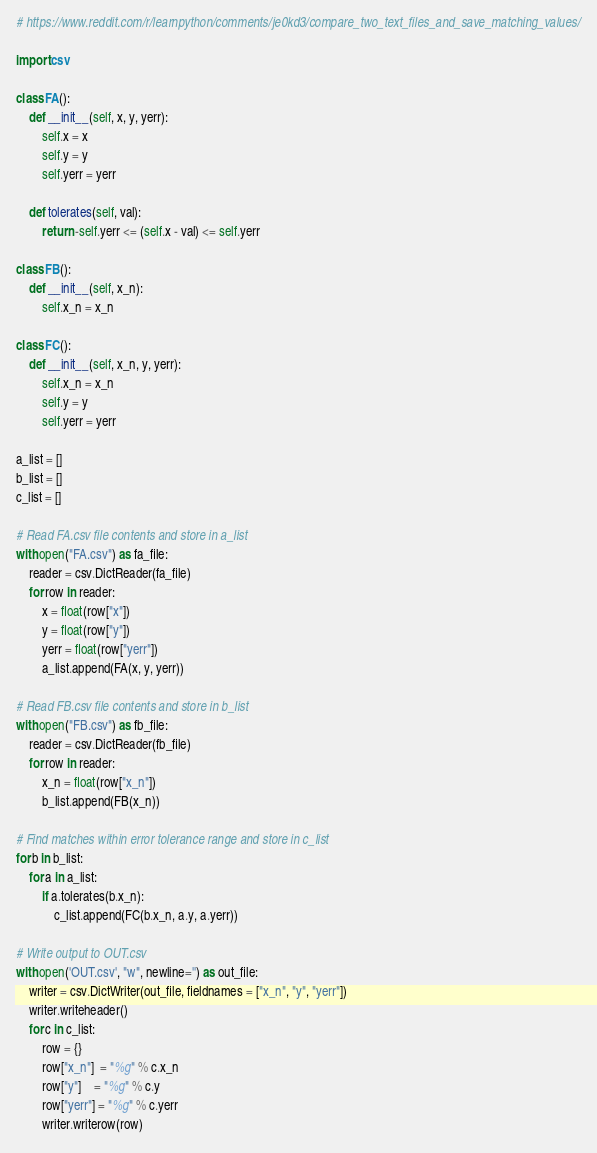Convert code to text. <code><loc_0><loc_0><loc_500><loc_500><_Python_># https://www.reddit.com/r/learnpython/comments/je0kd3/compare_two_text_files_and_save_matching_values/

import csv

class FA():
    def __init__(self, x, y, yerr):
        self.x = x
        self.y = y
        self.yerr = yerr

    def tolerates(self, val):
        return -self.yerr <= (self.x - val) <= self.yerr

class FB():
    def __init__(self, x_n):
        self.x_n = x_n

class FC():
    def __init__(self, x_n, y, yerr):
        self.x_n = x_n
        self.y = y
        self.yerr = yerr

a_list = []
b_list = []
c_list = []

# Read FA.csv file contents and store in a_list
with open("FA.csv") as fa_file:
    reader = csv.DictReader(fa_file)
    for row in reader:
        x = float(row["x"])
        y = float(row["y"])
        yerr = float(row["yerr"])
        a_list.append(FA(x, y, yerr))

# Read FB.csv file contents and store in b_list
with open("FB.csv") as fb_file:
    reader = csv.DictReader(fb_file)
    for row in reader:
        x_n = float(row["x_n"])
        b_list.append(FB(x_n))

# Find matches within error tolerance range and store in c_list
for b in b_list:
    for a in a_list:
        if a.tolerates(b.x_n):
            c_list.append(FC(b.x_n, a.y, a.yerr))

# Write output to OUT.csv
with open('OUT.csv', "w", newline='') as out_file:
    writer = csv.DictWriter(out_file, fieldnames = ["x_n", "y", "yerr"])
    writer.writeheader()
    for c in c_list:
        row = {}
        row["x_n"]  = "%g" % c.x_n
        row["y"]    = "%g" % c.y
        row["yerr"] = "%g" % c.yerr
        writer.writerow(row)</code> 